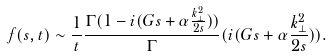Convert formula to latex. <formula><loc_0><loc_0><loc_500><loc_500>f ( s , t ) \sim \frac { 1 } { t } \frac { \Gamma ( 1 - i ( G s + \alpha \frac { k _ { \perp } ^ { 2 } } { 2 s } ) ) } \Gamma ( i ( G s + \alpha \frac { k _ { \perp } ^ { 2 } } { 2 s } ) ) .</formula> 